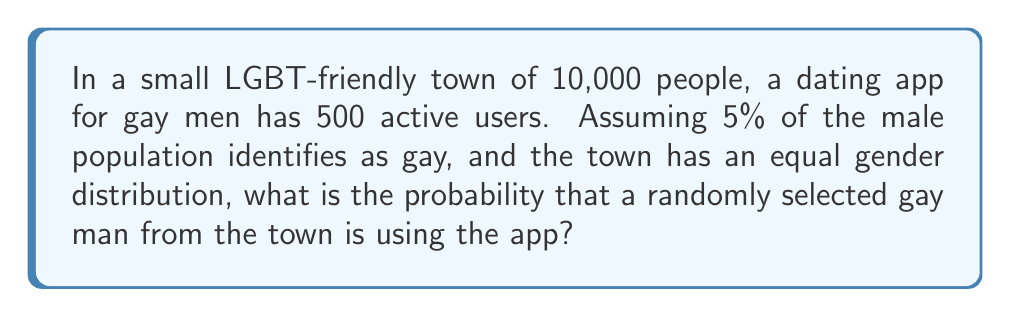Can you solve this math problem? Let's approach this step-by-step:

1. Calculate the number of men in the town:
   $$ \text{Number of men} = 10,000 \times 0.5 = 5,000 $$

2. Calculate the number of gay men in the town:
   $$ \text{Number of gay men} = 5,000 \times 0.05 = 250 $$

3. We know there are 500 active users on the app. However, this number might be higher than the actual number of gay men in the town. We need to consider the minimum of these two numbers:
   $$ \text{App users} = \min(500, 250) = 250 $$

4. The probability is calculated by dividing the number of gay men using the app by the total number of gay men in the town:

   $$ P(\text{Using app}) = \frac{\text{App users}}{\text{Total gay men}} = \frac{250}{250} = 1 $$

Therefore, the probability that a randomly selected gay man from the town is using the app is 1, or 100%.
Answer: 1 